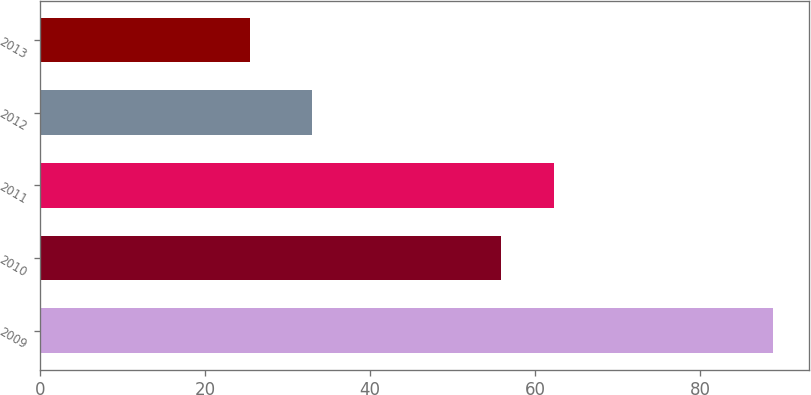<chart> <loc_0><loc_0><loc_500><loc_500><bar_chart><fcel>2009<fcel>2010<fcel>2011<fcel>2012<fcel>2013<nl><fcel>88.8<fcel>55.9<fcel>62.24<fcel>32.9<fcel>25.4<nl></chart> 